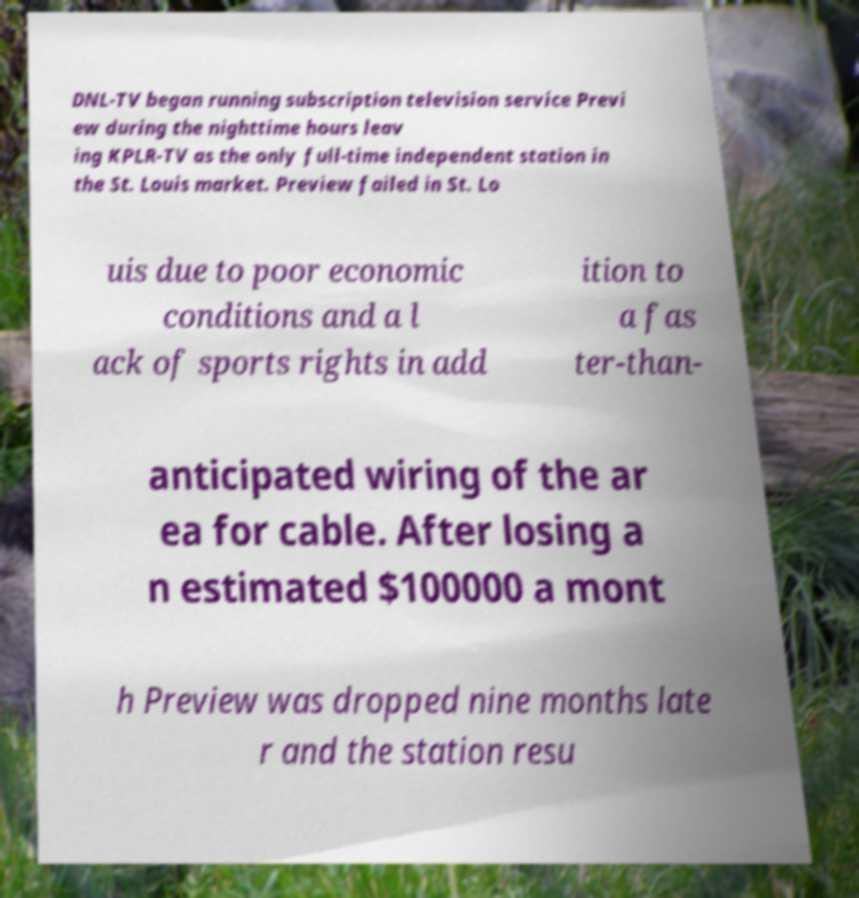Can you read and provide the text displayed in the image?This photo seems to have some interesting text. Can you extract and type it out for me? DNL-TV began running subscription television service Previ ew during the nighttime hours leav ing KPLR-TV as the only full-time independent station in the St. Louis market. Preview failed in St. Lo uis due to poor economic conditions and a l ack of sports rights in add ition to a fas ter-than- anticipated wiring of the ar ea for cable. After losing a n estimated $100000 a mont h Preview was dropped nine months late r and the station resu 